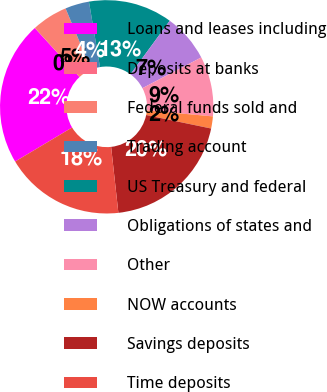Convert chart. <chart><loc_0><loc_0><loc_500><loc_500><pie_chart><fcel>Loans and leases including<fcel>Deposits at banks<fcel>Federal funds sold and<fcel>Trading account<fcel>US Treasury and federal<fcel>Obligations of states and<fcel>Other<fcel>NOW accounts<fcel>Savings deposits<fcel>Time deposits<nl><fcel>21.8%<fcel>0.01%<fcel>5.46%<fcel>3.64%<fcel>12.72%<fcel>7.28%<fcel>9.09%<fcel>1.83%<fcel>19.99%<fcel>18.17%<nl></chart> 